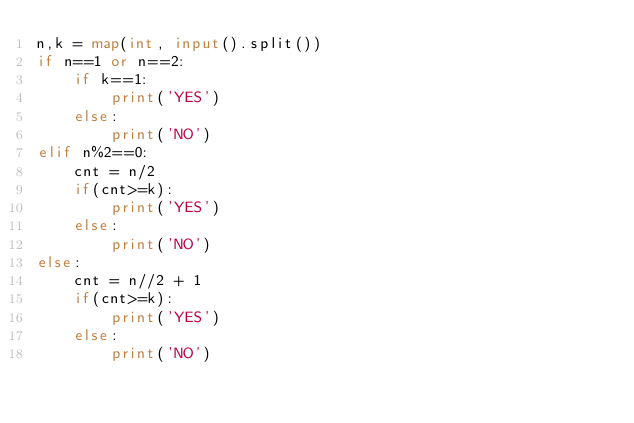Convert code to text. <code><loc_0><loc_0><loc_500><loc_500><_Python_>n,k = map(int, input().split())
if n==1 or n==2:
    if k==1:
        print('YES')
    else:
        print('NO')
elif n%2==0:
    cnt = n/2
    if(cnt>=k):
        print('YES')
    else:
        print('NO')
else:
    cnt = n//2 + 1
    if(cnt>=k):
        print('YES')
    else:
        print('NO')</code> 